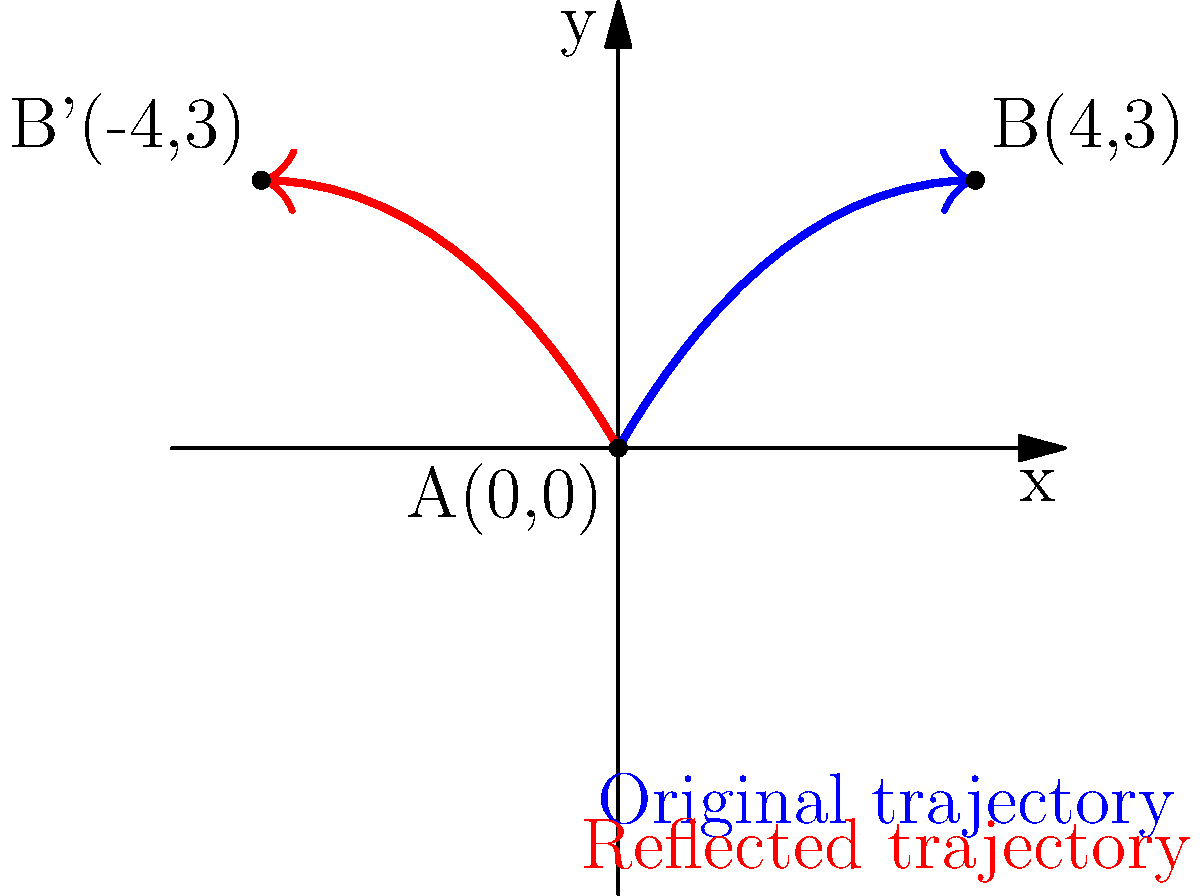In a romantic twist, Mlissa's protagonist sends a love letter that follows a parabolic path from point A(0,0) to point B(4,3). If the letter's trajectory is reflected across the y-axis, what are the coordinates of the endpoint B' of the reflected path? Let's approach this step-by-step:

1) The original path starts at A(0,0) and ends at B(4,3).

2) When reflecting a point across the y-axis:
   - The y-coordinate remains the same
   - The x-coordinate changes sign

3) For point B(4,3):
   - The x-coordinate is 4
   - The y-coordinate is 3

4) After reflection:
   - The new x-coordinate will be -4
   - The y-coordinate remains 3

5) Therefore, the coordinates of the reflected endpoint B' will be (-4,3).

This reflection creates a mirror image of the original love letter's path, symbolizing how love can often surprise us by taking unexpected routes!
Answer: $(-4,3)$ 